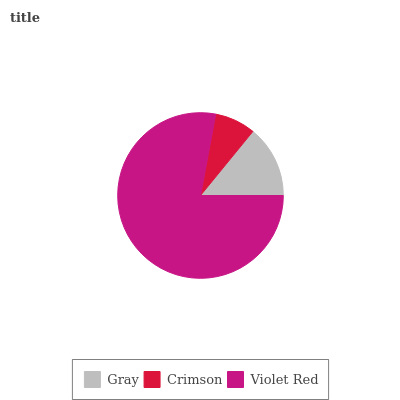Is Crimson the minimum?
Answer yes or no. Yes. Is Violet Red the maximum?
Answer yes or no. Yes. Is Violet Red the minimum?
Answer yes or no. No. Is Crimson the maximum?
Answer yes or no. No. Is Violet Red greater than Crimson?
Answer yes or no. Yes. Is Crimson less than Violet Red?
Answer yes or no. Yes. Is Crimson greater than Violet Red?
Answer yes or no. No. Is Violet Red less than Crimson?
Answer yes or no. No. Is Gray the high median?
Answer yes or no. Yes. Is Gray the low median?
Answer yes or no. Yes. Is Crimson the high median?
Answer yes or no. No. Is Violet Red the low median?
Answer yes or no. No. 